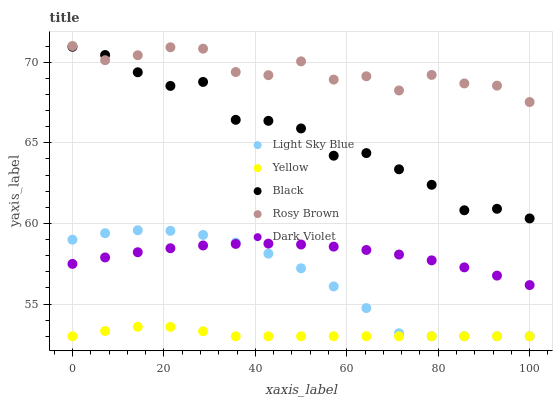Does Yellow have the minimum area under the curve?
Answer yes or no. Yes. Does Rosy Brown have the maximum area under the curve?
Answer yes or no. Yes. Does Light Sky Blue have the minimum area under the curve?
Answer yes or no. No. Does Light Sky Blue have the maximum area under the curve?
Answer yes or no. No. Is Yellow the smoothest?
Answer yes or no. Yes. Is Rosy Brown the roughest?
Answer yes or no. Yes. Is Light Sky Blue the smoothest?
Answer yes or no. No. Is Light Sky Blue the roughest?
Answer yes or no. No. Does Light Sky Blue have the lowest value?
Answer yes or no. Yes. Does Black have the lowest value?
Answer yes or no. No. Does Rosy Brown have the highest value?
Answer yes or no. Yes. Does Light Sky Blue have the highest value?
Answer yes or no. No. Is Yellow less than Black?
Answer yes or no. Yes. Is Rosy Brown greater than Yellow?
Answer yes or no. Yes. Does Yellow intersect Light Sky Blue?
Answer yes or no. Yes. Is Yellow less than Light Sky Blue?
Answer yes or no. No. Is Yellow greater than Light Sky Blue?
Answer yes or no. No. Does Yellow intersect Black?
Answer yes or no. No. 